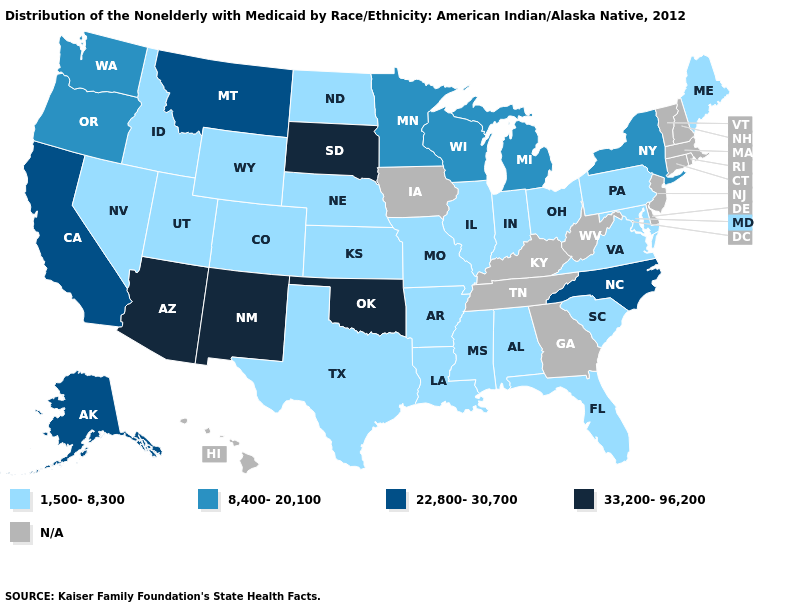Does the first symbol in the legend represent the smallest category?
Give a very brief answer. Yes. Does New York have the lowest value in the Northeast?
Short answer required. No. What is the highest value in states that border Vermont?
Short answer required. 8,400-20,100. What is the value of Wyoming?
Keep it brief. 1,500-8,300. Which states hav the highest value in the Northeast?
Concise answer only. New York. Does New York have the highest value in the Northeast?
Concise answer only. Yes. Name the states that have a value in the range 33,200-96,200?
Be succinct. Arizona, New Mexico, Oklahoma, South Dakota. Among the states that border North Carolina , which have the lowest value?
Answer briefly. South Carolina, Virginia. What is the value of Alabama?
Be succinct. 1,500-8,300. Does the map have missing data?
Quick response, please. Yes. What is the value of Delaware?
Quick response, please. N/A. What is the value of Louisiana?
Be succinct. 1,500-8,300. 